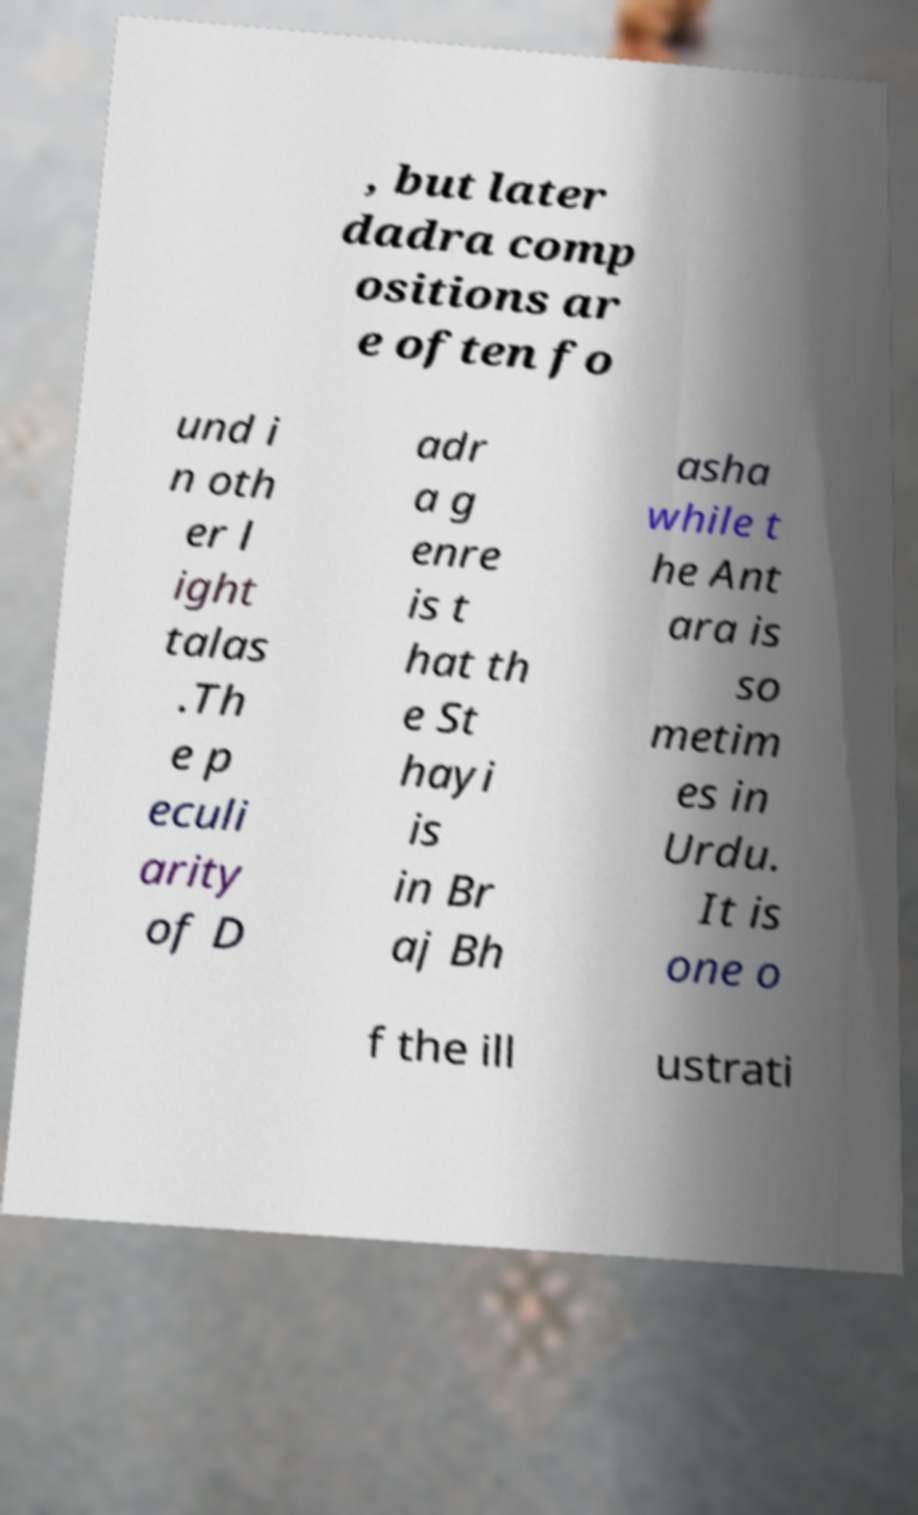What messages or text are displayed in this image? I need them in a readable, typed format. , but later dadra comp ositions ar e often fo und i n oth er l ight talas .Th e p eculi arity of D adr a g enre is t hat th e St hayi is in Br aj Bh asha while t he Ant ara is so metim es in Urdu. It is one o f the ill ustrati 